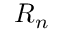<formula> <loc_0><loc_0><loc_500><loc_500>{ R } _ { n }</formula> 